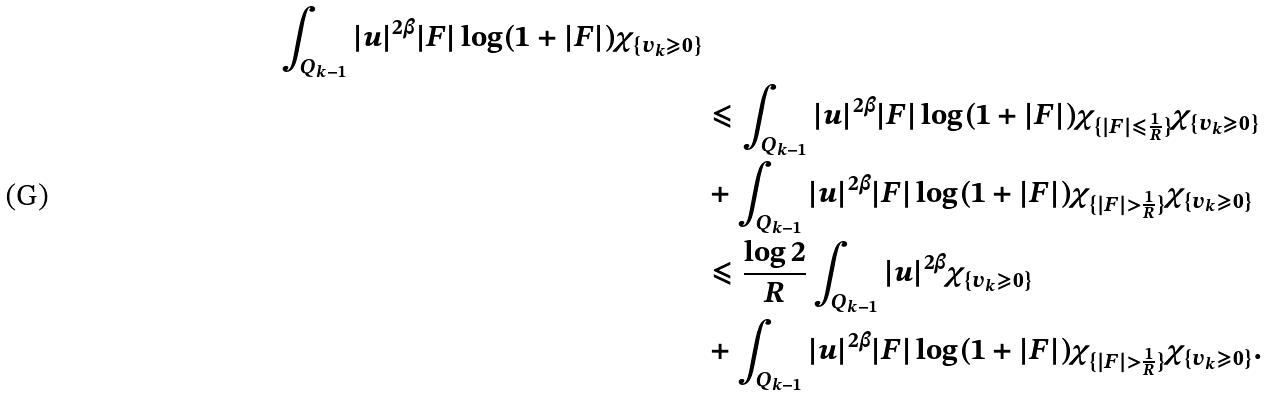Convert formula to latex. <formula><loc_0><loc_0><loc_500><loc_500>\int _ { Q _ { k - 1 } } | u | ^ { 2 \beta } | F | \log ( 1 + | F | ) \chi _ { \{ v _ { k } \geqslant 0 \} } \\ & \leqslant \int _ { Q _ { k - 1 } } | u | ^ { 2 \beta } | F | \log ( 1 + | F | ) \chi _ { \{ | F | \leqslant \frac { 1 } { R } \} } \chi _ { \{ v _ { k } \geqslant 0 \} } \\ & + \int _ { Q _ { k - 1 } } | u | ^ { 2 \beta } | F | \log ( 1 + | F | ) \chi _ { \{ | F | > \frac { 1 } { R } \} } \chi _ { \{ v _ { k } \geqslant 0 \} } \\ & \leqslant \frac { \log 2 } { R } \int _ { Q _ { k - 1 } } | u | ^ { 2 \beta } \chi _ { \{ v _ { k } \geqslant 0 \} } \\ & + \int _ { Q _ { k - 1 } } | u | ^ { 2 \beta } | F | \log ( 1 + | F | ) \chi _ { \{ | F | > \frac { 1 } { R } \} } \chi _ { \{ v _ { k } \geqslant 0 \} } .</formula> 